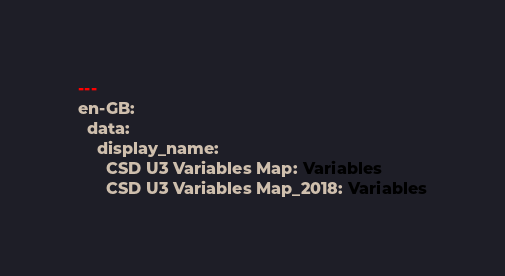Convert code to text. <code><loc_0><loc_0><loc_500><loc_500><_YAML_>---
en-GB:
  data:
    display_name:
      CSD U3 Variables Map: Variables
      CSD U3 Variables Map_2018: Variables
</code> 